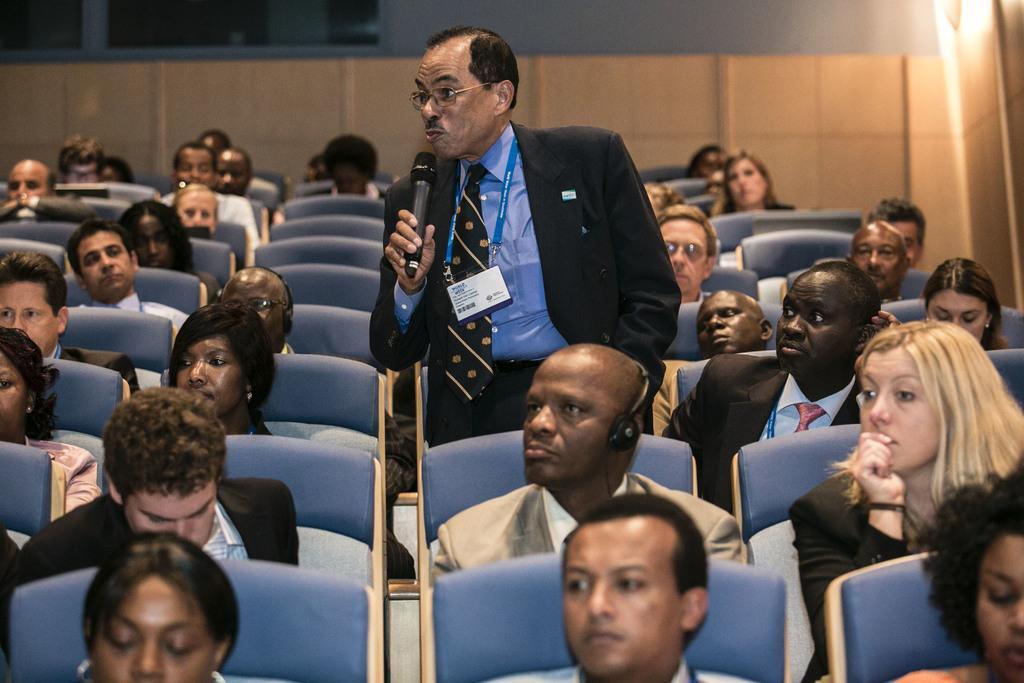How would you summarize this image in a sentence or two? In this picture there is a man who is wearing spectacle, blazer, shirt, tie and he is holding a mic. Besides him I can see many peoples were sitting on the chair. This room looks like an auditorium. In the top right corner I can see the light beams. 